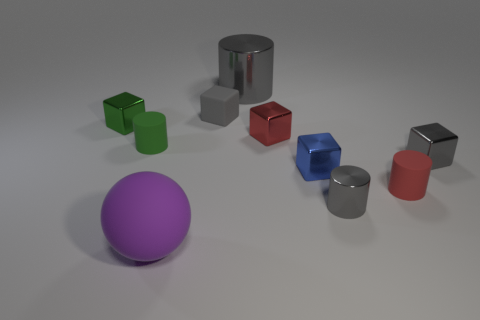There is a shiny cube that is the same color as the big cylinder; what is its size?
Your answer should be very brief. Small. Are there any purple objects made of the same material as the big cylinder?
Your response must be concise. No. What number of big things are both in front of the tiny green matte thing and right of the large purple ball?
Offer a very short reply. 0. There is a red cylinder in front of the tiny blue block; what material is it?
Keep it short and to the point. Rubber. The red cube that is the same material as the green block is what size?
Keep it short and to the point. Small. There is a tiny red shiny object; are there any big metal cylinders in front of it?
Keep it short and to the point. No. The red object that is the same shape as the small green rubber thing is what size?
Make the answer very short. Small. There is a large metal cylinder; does it have the same color as the rubber cylinder left of the small red rubber object?
Offer a very short reply. No. Do the large sphere and the large metallic object have the same color?
Keep it short and to the point. No. Are there fewer tiny metal blocks than big blue rubber cylinders?
Ensure brevity in your answer.  No. 